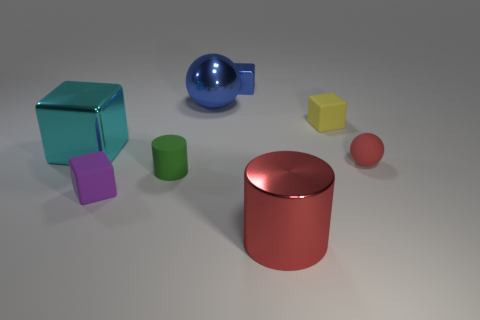Is the color of the metallic cylinder the same as the rubber sphere?
Your answer should be very brief. Yes. There is a cyan thing that is the same size as the blue metal sphere; what shape is it?
Make the answer very short. Cube. There is a tiny rubber cube that is right of the small rubber cylinder; is it the same color as the shiny sphere?
Keep it short and to the point. No. How many things are objects that are on the right side of the tiny yellow rubber object or tiny blue balls?
Your answer should be very brief. 1. Is the number of blue blocks that are on the right side of the red metal thing greater than the number of metallic cylinders behind the metallic ball?
Your answer should be compact. No. Is the green object made of the same material as the big sphere?
Your answer should be very brief. No. What is the shape of the large object that is both behind the purple matte block and right of the big cyan metal block?
Make the answer very short. Sphere. What shape is the red thing that is the same material as the small yellow block?
Provide a short and direct response. Sphere. Are there any large red shiny objects?
Provide a short and direct response. Yes. There is a rubber block in front of the small red object; is there a purple cube behind it?
Keep it short and to the point. No. 